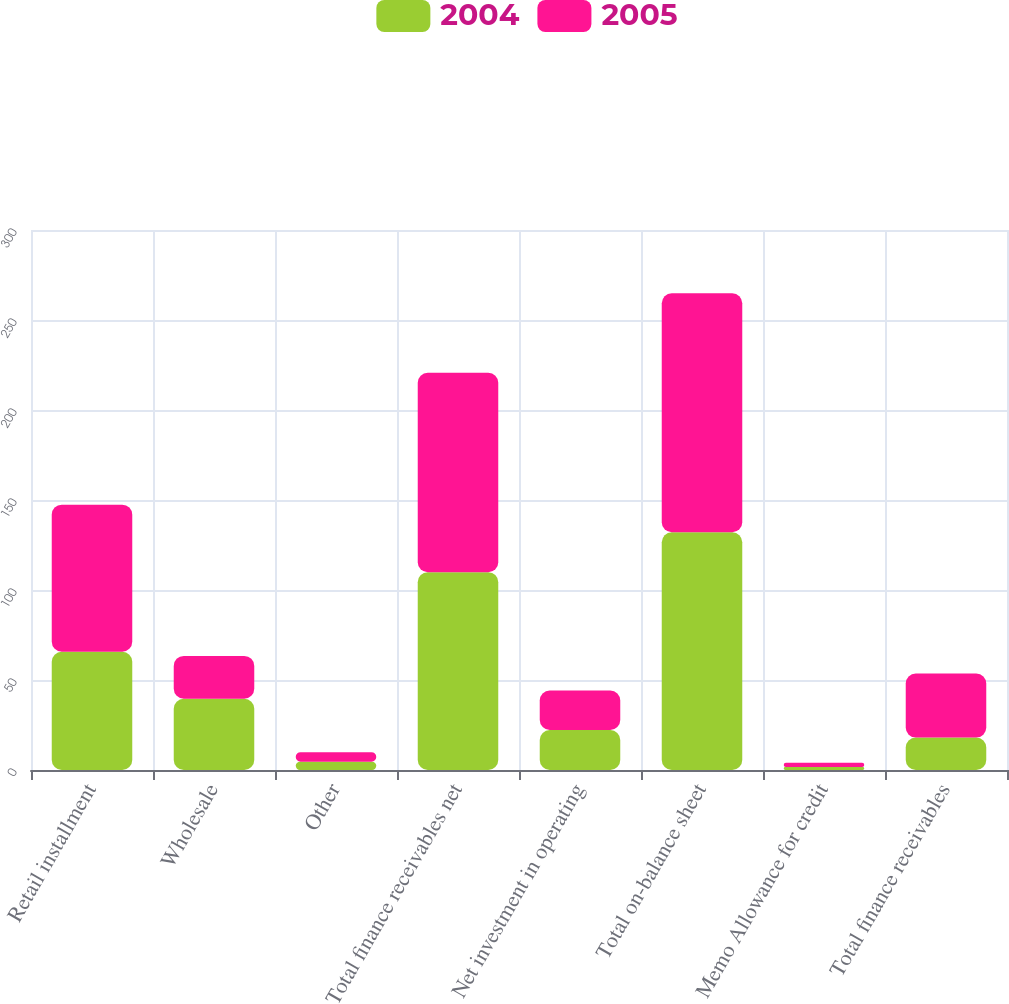Convert chart. <chart><loc_0><loc_0><loc_500><loc_500><stacked_bar_chart><ecel><fcel>Retail installment<fcel>Wholesale<fcel>Other<fcel>Total finance receivables net<fcel>Net investment in operating<fcel>Total on-balance sheet<fcel>Memo Allowance for credit<fcel>Total finance receivables<nl><fcel>2004<fcel>65.7<fcel>39.6<fcel>4.6<fcel>109.9<fcel>22.2<fcel>132.1<fcel>1.6<fcel>18<nl><fcel>2005<fcel>81.7<fcel>23.8<fcel>5.3<fcel>110.8<fcel>21.9<fcel>132.7<fcel>2.4<fcel>35.6<nl></chart> 